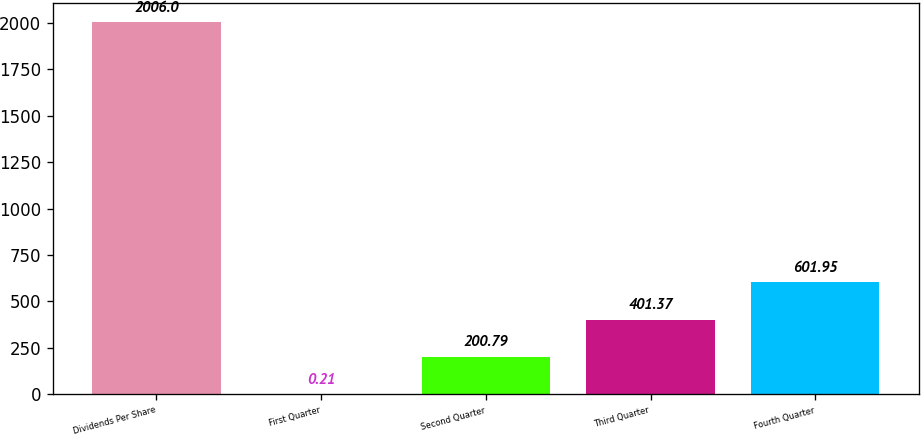<chart> <loc_0><loc_0><loc_500><loc_500><bar_chart><fcel>Dividends Per Share<fcel>First Quarter<fcel>Second Quarter<fcel>Third Quarter<fcel>Fourth Quarter<nl><fcel>2006<fcel>0.21<fcel>200.79<fcel>401.37<fcel>601.95<nl></chart> 